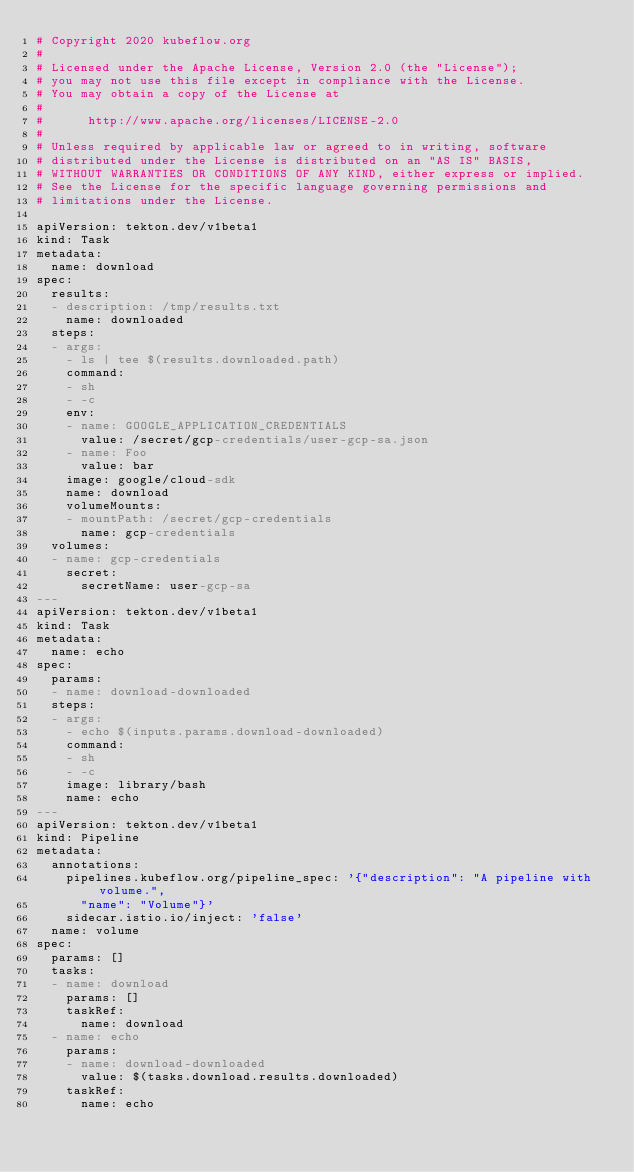<code> <loc_0><loc_0><loc_500><loc_500><_YAML_># Copyright 2020 kubeflow.org
#
# Licensed under the Apache License, Version 2.0 (the "License");
# you may not use this file except in compliance with the License.
# You may obtain a copy of the License at
#
#      http://www.apache.org/licenses/LICENSE-2.0
#
# Unless required by applicable law or agreed to in writing, software
# distributed under the License is distributed on an "AS IS" BASIS,
# WITHOUT WARRANTIES OR CONDITIONS OF ANY KIND, either express or implied.
# See the License for the specific language governing permissions and
# limitations under the License.

apiVersion: tekton.dev/v1beta1
kind: Task
metadata:
  name: download
spec:
  results:
  - description: /tmp/results.txt
    name: downloaded
  steps:
  - args:
    - ls | tee $(results.downloaded.path)
    command:
    - sh
    - -c
    env:
    - name: GOOGLE_APPLICATION_CREDENTIALS
      value: /secret/gcp-credentials/user-gcp-sa.json
    - name: Foo
      value: bar
    image: google/cloud-sdk
    name: download
    volumeMounts:
    - mountPath: /secret/gcp-credentials
      name: gcp-credentials
  volumes:
  - name: gcp-credentials
    secret:
      secretName: user-gcp-sa
---
apiVersion: tekton.dev/v1beta1
kind: Task
metadata:
  name: echo
spec:
  params:
  - name: download-downloaded
  steps:
  - args:
    - echo $(inputs.params.download-downloaded)
    command:
    - sh
    - -c
    image: library/bash
    name: echo
---
apiVersion: tekton.dev/v1beta1
kind: Pipeline
metadata:
  annotations:
    pipelines.kubeflow.org/pipeline_spec: '{"description": "A pipeline with volume.",
      "name": "Volume"}'
    sidecar.istio.io/inject: 'false'
  name: volume
spec:
  params: []
  tasks:
  - name: download
    params: []
    taskRef:
      name: download
  - name: echo
    params:
    - name: download-downloaded
      value: $(tasks.download.results.downloaded)
    taskRef:
      name: echo
</code> 